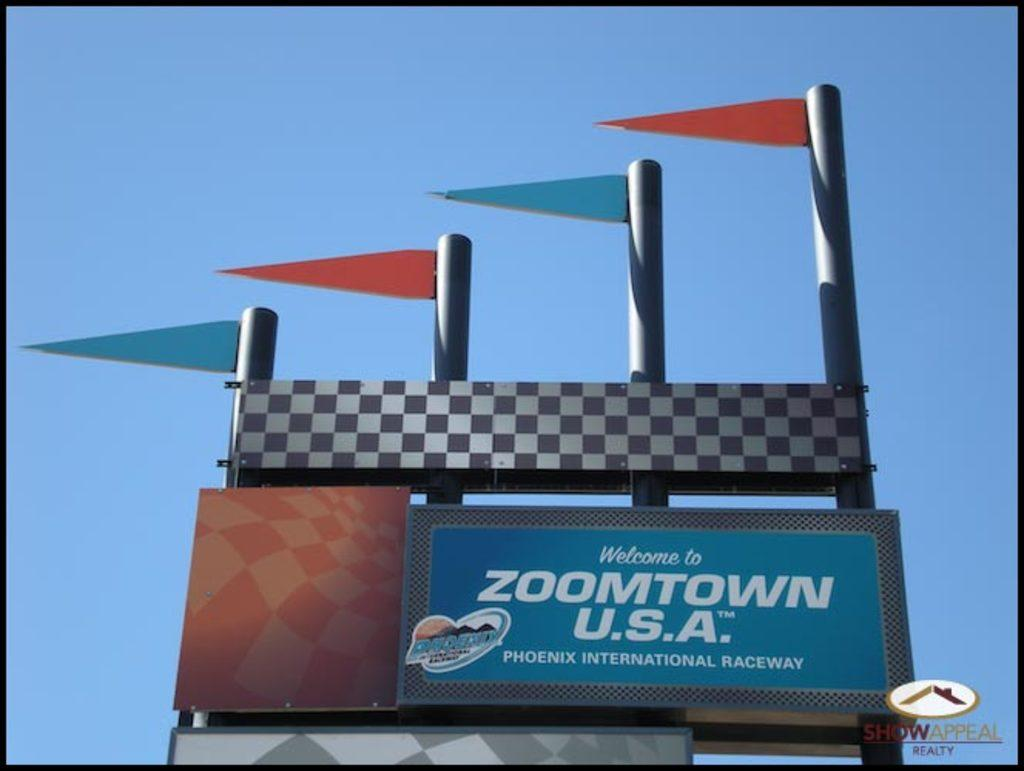Provide a one-sentence caption for the provided image. A billboard reads "Welcome to Zoomtown U.S.A.", which is in Phoenix. 